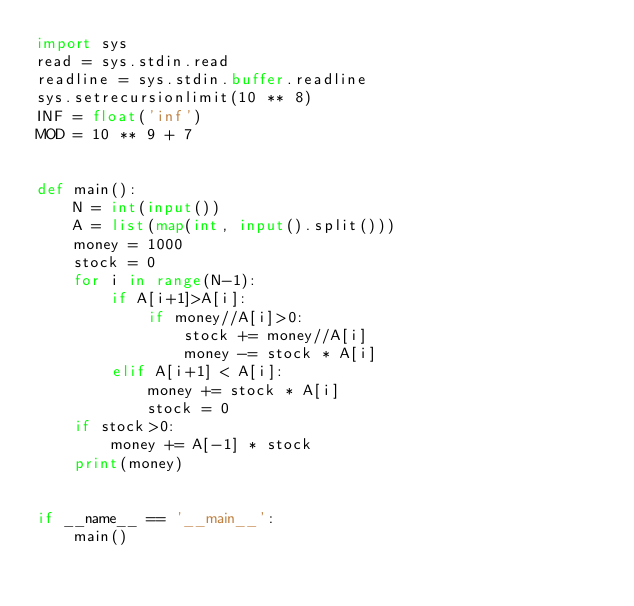<code> <loc_0><loc_0><loc_500><loc_500><_Python_>import sys
read = sys.stdin.read
readline = sys.stdin.buffer.readline
sys.setrecursionlimit(10 ** 8)
INF = float('inf')
MOD = 10 ** 9 + 7


def main():
    N = int(input())
    A = list(map(int, input().split()))
    money = 1000
    stock = 0
    for i in range(N-1):
        if A[i+1]>A[i]:
            if money//A[i]>0:
                stock += money//A[i]
                money -= stock * A[i]
        elif A[i+1] < A[i]:
            money += stock * A[i]
            stock = 0
    if stock>0:
        money += A[-1] * stock
    print(money)


if __name__ == '__main__':
    main()

</code> 